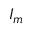Convert formula to latex. <formula><loc_0><loc_0><loc_500><loc_500>I _ { m }</formula> 